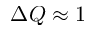<formula> <loc_0><loc_0><loc_500><loc_500>\Delta Q \approx 1</formula> 